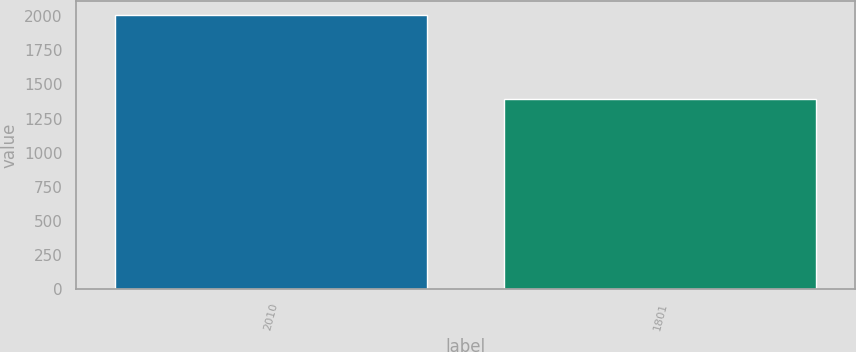<chart> <loc_0><loc_0><loc_500><loc_500><bar_chart><fcel>2010<fcel>1801<nl><fcel>2008<fcel>1396<nl></chart> 